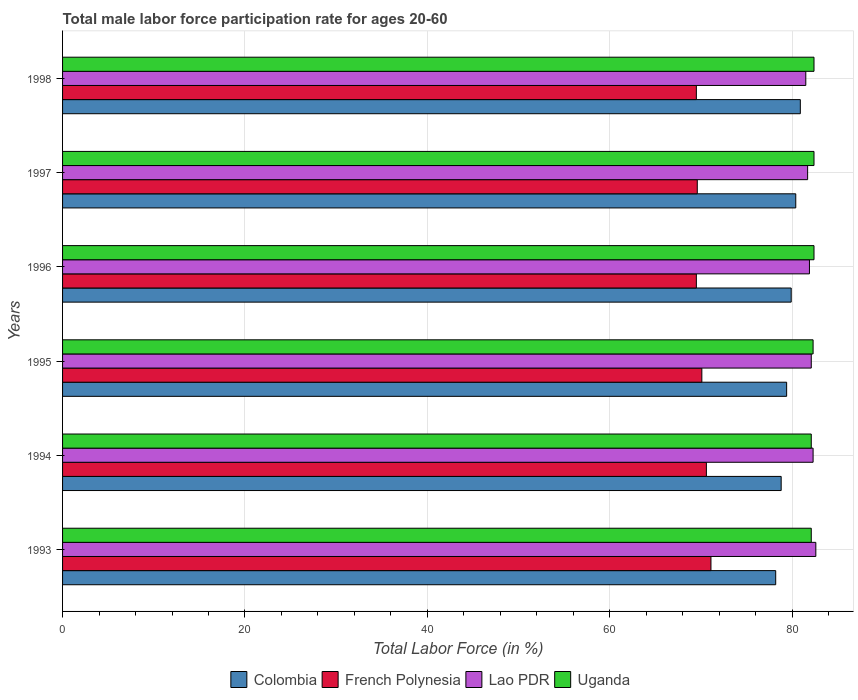How many different coloured bars are there?
Make the answer very short. 4. How many groups of bars are there?
Provide a succinct answer. 6. Are the number of bars per tick equal to the number of legend labels?
Offer a terse response. Yes. How many bars are there on the 2nd tick from the bottom?
Your response must be concise. 4. What is the label of the 1st group of bars from the top?
Offer a terse response. 1998. What is the male labor force participation rate in Lao PDR in 1998?
Provide a short and direct response. 81.5. Across all years, what is the maximum male labor force participation rate in Lao PDR?
Give a very brief answer. 82.6. Across all years, what is the minimum male labor force participation rate in Colombia?
Make the answer very short. 78.2. What is the total male labor force participation rate in Uganda in the graph?
Provide a short and direct response. 493.7. What is the difference between the male labor force participation rate in Colombia in 1994 and that in 1995?
Provide a succinct answer. -0.6. What is the difference between the male labor force participation rate in Lao PDR in 1994 and the male labor force participation rate in French Polynesia in 1996?
Provide a succinct answer. 12.8. What is the average male labor force participation rate in French Polynesia per year?
Keep it short and to the point. 70.07. In the year 1993, what is the difference between the male labor force participation rate in Colombia and male labor force participation rate in Lao PDR?
Keep it short and to the point. -4.4. What is the ratio of the male labor force participation rate in French Polynesia in 1993 to that in 1994?
Give a very brief answer. 1.01. Is the male labor force participation rate in Lao PDR in 1996 less than that in 1997?
Provide a succinct answer. No. Is the difference between the male labor force participation rate in Colombia in 1994 and 1997 greater than the difference between the male labor force participation rate in Lao PDR in 1994 and 1997?
Keep it short and to the point. No. What is the difference between the highest and the lowest male labor force participation rate in Colombia?
Offer a terse response. 2.7. In how many years, is the male labor force participation rate in Lao PDR greater than the average male labor force participation rate in Lao PDR taken over all years?
Ensure brevity in your answer.  3. Is the sum of the male labor force participation rate in French Polynesia in 1994 and 1995 greater than the maximum male labor force participation rate in Uganda across all years?
Make the answer very short. Yes. What does the 1st bar from the top in 1996 represents?
Your answer should be very brief. Uganda. What does the 3rd bar from the bottom in 1993 represents?
Your answer should be compact. Lao PDR. How many bars are there?
Provide a succinct answer. 24. How many years are there in the graph?
Provide a succinct answer. 6. Does the graph contain grids?
Ensure brevity in your answer.  Yes. Where does the legend appear in the graph?
Make the answer very short. Bottom center. How are the legend labels stacked?
Your answer should be compact. Horizontal. What is the title of the graph?
Offer a very short reply. Total male labor force participation rate for ages 20-60. Does "Mongolia" appear as one of the legend labels in the graph?
Provide a succinct answer. No. What is the label or title of the X-axis?
Provide a succinct answer. Total Labor Force (in %). What is the label or title of the Y-axis?
Your answer should be compact. Years. What is the Total Labor Force (in %) of Colombia in 1993?
Keep it short and to the point. 78.2. What is the Total Labor Force (in %) in French Polynesia in 1993?
Provide a succinct answer. 71.1. What is the Total Labor Force (in %) of Lao PDR in 1993?
Offer a very short reply. 82.6. What is the Total Labor Force (in %) in Uganda in 1993?
Your response must be concise. 82.1. What is the Total Labor Force (in %) of Colombia in 1994?
Your response must be concise. 78.8. What is the Total Labor Force (in %) in French Polynesia in 1994?
Your answer should be compact. 70.6. What is the Total Labor Force (in %) in Lao PDR in 1994?
Offer a terse response. 82.3. What is the Total Labor Force (in %) in Uganda in 1994?
Provide a short and direct response. 82.1. What is the Total Labor Force (in %) of Colombia in 1995?
Make the answer very short. 79.4. What is the Total Labor Force (in %) in French Polynesia in 1995?
Your answer should be compact. 70.1. What is the Total Labor Force (in %) of Lao PDR in 1995?
Make the answer very short. 82.1. What is the Total Labor Force (in %) of Uganda in 1995?
Your answer should be very brief. 82.3. What is the Total Labor Force (in %) in Colombia in 1996?
Offer a terse response. 79.9. What is the Total Labor Force (in %) in French Polynesia in 1996?
Offer a terse response. 69.5. What is the Total Labor Force (in %) in Lao PDR in 1996?
Offer a very short reply. 81.9. What is the Total Labor Force (in %) in Uganda in 1996?
Your answer should be very brief. 82.4. What is the Total Labor Force (in %) of Colombia in 1997?
Offer a terse response. 80.4. What is the Total Labor Force (in %) of French Polynesia in 1997?
Your response must be concise. 69.6. What is the Total Labor Force (in %) in Lao PDR in 1997?
Give a very brief answer. 81.7. What is the Total Labor Force (in %) in Uganda in 1997?
Your answer should be compact. 82.4. What is the Total Labor Force (in %) of Colombia in 1998?
Your answer should be very brief. 80.9. What is the Total Labor Force (in %) in French Polynesia in 1998?
Provide a short and direct response. 69.5. What is the Total Labor Force (in %) in Lao PDR in 1998?
Your answer should be very brief. 81.5. What is the Total Labor Force (in %) in Uganda in 1998?
Your response must be concise. 82.4. Across all years, what is the maximum Total Labor Force (in %) in Colombia?
Provide a short and direct response. 80.9. Across all years, what is the maximum Total Labor Force (in %) of French Polynesia?
Your answer should be compact. 71.1. Across all years, what is the maximum Total Labor Force (in %) of Lao PDR?
Your response must be concise. 82.6. Across all years, what is the maximum Total Labor Force (in %) in Uganda?
Provide a short and direct response. 82.4. Across all years, what is the minimum Total Labor Force (in %) of Colombia?
Provide a succinct answer. 78.2. Across all years, what is the minimum Total Labor Force (in %) of French Polynesia?
Keep it short and to the point. 69.5. Across all years, what is the minimum Total Labor Force (in %) of Lao PDR?
Provide a short and direct response. 81.5. Across all years, what is the minimum Total Labor Force (in %) of Uganda?
Give a very brief answer. 82.1. What is the total Total Labor Force (in %) in Colombia in the graph?
Your answer should be very brief. 477.6. What is the total Total Labor Force (in %) in French Polynesia in the graph?
Provide a succinct answer. 420.4. What is the total Total Labor Force (in %) in Lao PDR in the graph?
Offer a very short reply. 492.1. What is the total Total Labor Force (in %) in Uganda in the graph?
Your response must be concise. 493.7. What is the difference between the Total Labor Force (in %) of Uganda in 1993 and that in 1994?
Your answer should be very brief. 0. What is the difference between the Total Labor Force (in %) in French Polynesia in 1993 and that in 1995?
Offer a terse response. 1. What is the difference between the Total Labor Force (in %) in Lao PDR in 1993 and that in 1995?
Keep it short and to the point. 0.5. What is the difference between the Total Labor Force (in %) in Uganda in 1993 and that in 1995?
Provide a short and direct response. -0.2. What is the difference between the Total Labor Force (in %) in Colombia in 1993 and that in 1996?
Your answer should be compact. -1.7. What is the difference between the Total Labor Force (in %) in French Polynesia in 1993 and that in 1996?
Offer a very short reply. 1.6. What is the difference between the Total Labor Force (in %) in Lao PDR in 1993 and that in 1996?
Your answer should be compact. 0.7. What is the difference between the Total Labor Force (in %) in Uganda in 1993 and that in 1996?
Keep it short and to the point. -0.3. What is the difference between the Total Labor Force (in %) in Colombia in 1993 and that in 1997?
Keep it short and to the point. -2.2. What is the difference between the Total Labor Force (in %) of Lao PDR in 1993 and that in 1997?
Your response must be concise. 0.9. What is the difference between the Total Labor Force (in %) in French Polynesia in 1993 and that in 1998?
Ensure brevity in your answer.  1.6. What is the difference between the Total Labor Force (in %) of French Polynesia in 1994 and that in 1995?
Ensure brevity in your answer.  0.5. What is the difference between the Total Labor Force (in %) in Lao PDR in 1994 and that in 1995?
Provide a succinct answer. 0.2. What is the difference between the Total Labor Force (in %) of Uganda in 1994 and that in 1995?
Offer a terse response. -0.2. What is the difference between the Total Labor Force (in %) in French Polynesia in 1994 and that in 1996?
Your answer should be very brief. 1.1. What is the difference between the Total Labor Force (in %) of French Polynesia in 1994 and that in 1997?
Your answer should be very brief. 1. What is the difference between the Total Labor Force (in %) of Lao PDR in 1994 and that in 1997?
Offer a very short reply. 0.6. What is the difference between the Total Labor Force (in %) of French Polynesia in 1994 and that in 1998?
Offer a very short reply. 1.1. What is the difference between the Total Labor Force (in %) of Lao PDR in 1994 and that in 1998?
Your response must be concise. 0.8. What is the difference between the Total Labor Force (in %) of Uganda in 1994 and that in 1998?
Your response must be concise. -0.3. What is the difference between the Total Labor Force (in %) in Lao PDR in 1995 and that in 1996?
Offer a terse response. 0.2. What is the difference between the Total Labor Force (in %) of Colombia in 1995 and that in 1997?
Your response must be concise. -1. What is the difference between the Total Labor Force (in %) in French Polynesia in 1995 and that in 1997?
Offer a terse response. 0.5. What is the difference between the Total Labor Force (in %) in Uganda in 1995 and that in 1997?
Make the answer very short. -0.1. What is the difference between the Total Labor Force (in %) in Colombia in 1996 and that in 1997?
Your response must be concise. -0.5. What is the difference between the Total Labor Force (in %) of Uganda in 1996 and that in 1997?
Make the answer very short. 0. What is the difference between the Total Labor Force (in %) of Lao PDR in 1996 and that in 1998?
Give a very brief answer. 0.4. What is the difference between the Total Labor Force (in %) of Uganda in 1996 and that in 1998?
Offer a terse response. 0. What is the difference between the Total Labor Force (in %) of Lao PDR in 1997 and that in 1998?
Ensure brevity in your answer.  0.2. What is the difference between the Total Labor Force (in %) in Colombia in 1993 and the Total Labor Force (in %) in Uganda in 1994?
Offer a terse response. -3.9. What is the difference between the Total Labor Force (in %) in French Polynesia in 1993 and the Total Labor Force (in %) in Uganda in 1994?
Your answer should be compact. -11. What is the difference between the Total Labor Force (in %) in Colombia in 1993 and the Total Labor Force (in %) in French Polynesia in 1995?
Offer a terse response. 8.1. What is the difference between the Total Labor Force (in %) of French Polynesia in 1993 and the Total Labor Force (in %) of Uganda in 1995?
Offer a terse response. -11.2. What is the difference between the Total Labor Force (in %) in Colombia in 1993 and the Total Labor Force (in %) in French Polynesia in 1996?
Offer a very short reply. 8.7. What is the difference between the Total Labor Force (in %) in Colombia in 1993 and the Total Labor Force (in %) in Lao PDR in 1996?
Provide a short and direct response. -3.7. What is the difference between the Total Labor Force (in %) in Colombia in 1993 and the Total Labor Force (in %) in Uganda in 1996?
Offer a very short reply. -4.2. What is the difference between the Total Labor Force (in %) in French Polynesia in 1993 and the Total Labor Force (in %) in Uganda in 1996?
Offer a very short reply. -11.3. What is the difference between the Total Labor Force (in %) in Colombia in 1993 and the Total Labor Force (in %) in Lao PDR in 1997?
Make the answer very short. -3.5. What is the difference between the Total Labor Force (in %) in Colombia in 1993 and the Total Labor Force (in %) in Uganda in 1997?
Keep it short and to the point. -4.2. What is the difference between the Total Labor Force (in %) in French Polynesia in 1993 and the Total Labor Force (in %) in Lao PDR in 1997?
Your answer should be very brief. -10.6. What is the difference between the Total Labor Force (in %) of French Polynesia in 1993 and the Total Labor Force (in %) of Uganda in 1997?
Offer a terse response. -11.3. What is the difference between the Total Labor Force (in %) of Colombia in 1993 and the Total Labor Force (in %) of Uganda in 1998?
Keep it short and to the point. -4.2. What is the difference between the Total Labor Force (in %) in Lao PDR in 1993 and the Total Labor Force (in %) in Uganda in 1998?
Your response must be concise. 0.2. What is the difference between the Total Labor Force (in %) of Colombia in 1994 and the Total Labor Force (in %) of French Polynesia in 1995?
Ensure brevity in your answer.  8.7. What is the difference between the Total Labor Force (in %) in Colombia in 1994 and the Total Labor Force (in %) in Lao PDR in 1995?
Your response must be concise. -3.3. What is the difference between the Total Labor Force (in %) of French Polynesia in 1994 and the Total Labor Force (in %) of Uganda in 1995?
Provide a short and direct response. -11.7. What is the difference between the Total Labor Force (in %) in Lao PDR in 1994 and the Total Labor Force (in %) in Uganda in 1995?
Offer a terse response. 0. What is the difference between the Total Labor Force (in %) in Colombia in 1994 and the Total Labor Force (in %) in French Polynesia in 1996?
Your answer should be compact. 9.3. What is the difference between the Total Labor Force (in %) in Colombia in 1994 and the Total Labor Force (in %) in Lao PDR in 1996?
Give a very brief answer. -3.1. What is the difference between the Total Labor Force (in %) in French Polynesia in 1994 and the Total Labor Force (in %) in Lao PDR in 1996?
Offer a terse response. -11.3. What is the difference between the Total Labor Force (in %) of French Polynesia in 1994 and the Total Labor Force (in %) of Uganda in 1996?
Provide a succinct answer. -11.8. What is the difference between the Total Labor Force (in %) of Colombia in 1994 and the Total Labor Force (in %) of French Polynesia in 1997?
Your response must be concise. 9.2. What is the difference between the Total Labor Force (in %) of Colombia in 1994 and the Total Labor Force (in %) of Lao PDR in 1997?
Offer a very short reply. -2.9. What is the difference between the Total Labor Force (in %) of French Polynesia in 1994 and the Total Labor Force (in %) of Uganda in 1997?
Your response must be concise. -11.8. What is the difference between the Total Labor Force (in %) of Colombia in 1994 and the Total Labor Force (in %) of Uganda in 1998?
Give a very brief answer. -3.6. What is the difference between the Total Labor Force (in %) in French Polynesia in 1994 and the Total Labor Force (in %) in Lao PDR in 1998?
Your answer should be very brief. -10.9. What is the difference between the Total Labor Force (in %) in Colombia in 1995 and the Total Labor Force (in %) in Uganda in 1996?
Provide a succinct answer. -3. What is the difference between the Total Labor Force (in %) of French Polynesia in 1995 and the Total Labor Force (in %) of Uganda in 1996?
Ensure brevity in your answer.  -12.3. What is the difference between the Total Labor Force (in %) in Lao PDR in 1995 and the Total Labor Force (in %) in Uganda in 1996?
Give a very brief answer. -0.3. What is the difference between the Total Labor Force (in %) in Colombia in 1995 and the Total Labor Force (in %) in Uganda in 1997?
Your answer should be compact. -3. What is the difference between the Total Labor Force (in %) in French Polynesia in 1995 and the Total Labor Force (in %) in Lao PDR in 1997?
Provide a short and direct response. -11.6. What is the difference between the Total Labor Force (in %) of Lao PDR in 1995 and the Total Labor Force (in %) of Uganda in 1997?
Make the answer very short. -0.3. What is the difference between the Total Labor Force (in %) in Colombia in 1995 and the Total Labor Force (in %) in Lao PDR in 1998?
Ensure brevity in your answer.  -2.1. What is the difference between the Total Labor Force (in %) of Colombia in 1995 and the Total Labor Force (in %) of Uganda in 1998?
Your answer should be very brief. -3. What is the difference between the Total Labor Force (in %) of French Polynesia in 1996 and the Total Labor Force (in %) of Uganda in 1997?
Provide a short and direct response. -12.9. What is the difference between the Total Labor Force (in %) in Lao PDR in 1996 and the Total Labor Force (in %) in Uganda in 1997?
Provide a short and direct response. -0.5. What is the difference between the Total Labor Force (in %) of Colombia in 1996 and the Total Labor Force (in %) of Lao PDR in 1998?
Keep it short and to the point. -1.6. What is the difference between the Total Labor Force (in %) of French Polynesia in 1996 and the Total Labor Force (in %) of Lao PDR in 1998?
Give a very brief answer. -12. What is the difference between the Total Labor Force (in %) of Colombia in 1997 and the Total Labor Force (in %) of Lao PDR in 1998?
Your answer should be compact. -1.1. What is the difference between the Total Labor Force (in %) in Lao PDR in 1997 and the Total Labor Force (in %) in Uganda in 1998?
Make the answer very short. -0.7. What is the average Total Labor Force (in %) in Colombia per year?
Your answer should be compact. 79.6. What is the average Total Labor Force (in %) in French Polynesia per year?
Make the answer very short. 70.07. What is the average Total Labor Force (in %) in Lao PDR per year?
Give a very brief answer. 82.02. What is the average Total Labor Force (in %) in Uganda per year?
Your response must be concise. 82.28. In the year 1993, what is the difference between the Total Labor Force (in %) of French Polynesia and Total Labor Force (in %) of Lao PDR?
Provide a succinct answer. -11.5. In the year 1993, what is the difference between the Total Labor Force (in %) in French Polynesia and Total Labor Force (in %) in Uganda?
Your response must be concise. -11. In the year 1993, what is the difference between the Total Labor Force (in %) in Lao PDR and Total Labor Force (in %) in Uganda?
Give a very brief answer. 0.5. In the year 1994, what is the difference between the Total Labor Force (in %) of Colombia and Total Labor Force (in %) of French Polynesia?
Ensure brevity in your answer.  8.2. In the year 1994, what is the difference between the Total Labor Force (in %) in Colombia and Total Labor Force (in %) in Lao PDR?
Make the answer very short. -3.5. In the year 1994, what is the difference between the Total Labor Force (in %) in French Polynesia and Total Labor Force (in %) in Uganda?
Offer a terse response. -11.5. In the year 1994, what is the difference between the Total Labor Force (in %) in Lao PDR and Total Labor Force (in %) in Uganda?
Offer a very short reply. 0.2. In the year 1995, what is the difference between the Total Labor Force (in %) in Colombia and Total Labor Force (in %) in Uganda?
Keep it short and to the point. -2.9. In the year 1996, what is the difference between the Total Labor Force (in %) in Colombia and Total Labor Force (in %) in French Polynesia?
Your answer should be compact. 10.4. In the year 1996, what is the difference between the Total Labor Force (in %) in Colombia and Total Labor Force (in %) in Lao PDR?
Offer a terse response. -2. In the year 1996, what is the difference between the Total Labor Force (in %) of Colombia and Total Labor Force (in %) of Uganda?
Ensure brevity in your answer.  -2.5. In the year 1996, what is the difference between the Total Labor Force (in %) in Lao PDR and Total Labor Force (in %) in Uganda?
Your answer should be very brief. -0.5. In the year 1997, what is the difference between the Total Labor Force (in %) in Colombia and Total Labor Force (in %) in Uganda?
Ensure brevity in your answer.  -2. In the year 1997, what is the difference between the Total Labor Force (in %) of French Polynesia and Total Labor Force (in %) of Uganda?
Provide a short and direct response. -12.8. In the year 1997, what is the difference between the Total Labor Force (in %) in Lao PDR and Total Labor Force (in %) in Uganda?
Offer a very short reply. -0.7. In the year 1998, what is the difference between the Total Labor Force (in %) of Colombia and Total Labor Force (in %) of French Polynesia?
Keep it short and to the point. 11.4. In the year 1998, what is the difference between the Total Labor Force (in %) of Colombia and Total Labor Force (in %) of Lao PDR?
Keep it short and to the point. -0.6. In the year 1998, what is the difference between the Total Labor Force (in %) of Lao PDR and Total Labor Force (in %) of Uganda?
Offer a very short reply. -0.9. What is the ratio of the Total Labor Force (in %) in Colombia in 1993 to that in 1994?
Provide a succinct answer. 0.99. What is the ratio of the Total Labor Force (in %) of French Polynesia in 1993 to that in 1994?
Provide a short and direct response. 1.01. What is the ratio of the Total Labor Force (in %) of Lao PDR in 1993 to that in 1994?
Provide a succinct answer. 1. What is the ratio of the Total Labor Force (in %) in Uganda in 1993 to that in 1994?
Provide a succinct answer. 1. What is the ratio of the Total Labor Force (in %) in Colombia in 1993 to that in 1995?
Your answer should be very brief. 0.98. What is the ratio of the Total Labor Force (in %) of French Polynesia in 1993 to that in 1995?
Your answer should be very brief. 1.01. What is the ratio of the Total Labor Force (in %) in Colombia in 1993 to that in 1996?
Give a very brief answer. 0.98. What is the ratio of the Total Labor Force (in %) of French Polynesia in 1993 to that in 1996?
Offer a very short reply. 1.02. What is the ratio of the Total Labor Force (in %) of Lao PDR in 1993 to that in 1996?
Keep it short and to the point. 1.01. What is the ratio of the Total Labor Force (in %) in Uganda in 1993 to that in 1996?
Provide a short and direct response. 1. What is the ratio of the Total Labor Force (in %) of Colombia in 1993 to that in 1997?
Ensure brevity in your answer.  0.97. What is the ratio of the Total Labor Force (in %) of French Polynesia in 1993 to that in 1997?
Your response must be concise. 1.02. What is the ratio of the Total Labor Force (in %) in Colombia in 1993 to that in 1998?
Offer a terse response. 0.97. What is the ratio of the Total Labor Force (in %) in French Polynesia in 1993 to that in 1998?
Keep it short and to the point. 1.02. What is the ratio of the Total Labor Force (in %) of Lao PDR in 1993 to that in 1998?
Provide a succinct answer. 1.01. What is the ratio of the Total Labor Force (in %) in Uganda in 1993 to that in 1998?
Offer a very short reply. 1. What is the ratio of the Total Labor Force (in %) in Colombia in 1994 to that in 1995?
Provide a succinct answer. 0.99. What is the ratio of the Total Labor Force (in %) in French Polynesia in 1994 to that in 1995?
Give a very brief answer. 1.01. What is the ratio of the Total Labor Force (in %) of Lao PDR in 1994 to that in 1995?
Provide a short and direct response. 1. What is the ratio of the Total Labor Force (in %) in Colombia in 1994 to that in 1996?
Your answer should be very brief. 0.99. What is the ratio of the Total Labor Force (in %) in French Polynesia in 1994 to that in 1996?
Offer a terse response. 1.02. What is the ratio of the Total Labor Force (in %) in Uganda in 1994 to that in 1996?
Offer a terse response. 1. What is the ratio of the Total Labor Force (in %) of Colombia in 1994 to that in 1997?
Your answer should be very brief. 0.98. What is the ratio of the Total Labor Force (in %) of French Polynesia in 1994 to that in 1997?
Provide a short and direct response. 1.01. What is the ratio of the Total Labor Force (in %) in Lao PDR in 1994 to that in 1997?
Offer a very short reply. 1.01. What is the ratio of the Total Labor Force (in %) of Colombia in 1994 to that in 1998?
Your answer should be very brief. 0.97. What is the ratio of the Total Labor Force (in %) of French Polynesia in 1994 to that in 1998?
Keep it short and to the point. 1.02. What is the ratio of the Total Labor Force (in %) in Lao PDR in 1994 to that in 1998?
Make the answer very short. 1.01. What is the ratio of the Total Labor Force (in %) in Uganda in 1994 to that in 1998?
Make the answer very short. 1. What is the ratio of the Total Labor Force (in %) in Colombia in 1995 to that in 1996?
Ensure brevity in your answer.  0.99. What is the ratio of the Total Labor Force (in %) of French Polynesia in 1995 to that in 1996?
Your answer should be compact. 1.01. What is the ratio of the Total Labor Force (in %) in Lao PDR in 1995 to that in 1996?
Your answer should be very brief. 1. What is the ratio of the Total Labor Force (in %) in Colombia in 1995 to that in 1997?
Your response must be concise. 0.99. What is the ratio of the Total Labor Force (in %) of French Polynesia in 1995 to that in 1997?
Give a very brief answer. 1.01. What is the ratio of the Total Labor Force (in %) of Lao PDR in 1995 to that in 1997?
Your response must be concise. 1. What is the ratio of the Total Labor Force (in %) of Uganda in 1995 to that in 1997?
Your response must be concise. 1. What is the ratio of the Total Labor Force (in %) of Colombia in 1995 to that in 1998?
Offer a terse response. 0.98. What is the ratio of the Total Labor Force (in %) in French Polynesia in 1995 to that in 1998?
Make the answer very short. 1.01. What is the ratio of the Total Labor Force (in %) of Lao PDR in 1995 to that in 1998?
Provide a short and direct response. 1.01. What is the ratio of the Total Labor Force (in %) of Colombia in 1996 to that in 1997?
Ensure brevity in your answer.  0.99. What is the ratio of the Total Labor Force (in %) of Lao PDR in 1996 to that in 1997?
Your response must be concise. 1. What is the ratio of the Total Labor Force (in %) of Uganda in 1996 to that in 1997?
Give a very brief answer. 1. What is the ratio of the Total Labor Force (in %) of Colombia in 1996 to that in 1998?
Make the answer very short. 0.99. What is the ratio of the Total Labor Force (in %) in Lao PDR in 1996 to that in 1998?
Offer a terse response. 1. What is the ratio of the Total Labor Force (in %) in Uganda in 1996 to that in 1998?
Offer a terse response. 1. What is the ratio of the Total Labor Force (in %) in Lao PDR in 1997 to that in 1998?
Provide a succinct answer. 1. What is the difference between the highest and the second highest Total Labor Force (in %) in Colombia?
Give a very brief answer. 0.5. What is the difference between the highest and the second highest Total Labor Force (in %) of Lao PDR?
Keep it short and to the point. 0.3. What is the difference between the highest and the second highest Total Labor Force (in %) of Uganda?
Provide a short and direct response. 0. What is the difference between the highest and the lowest Total Labor Force (in %) of Lao PDR?
Provide a short and direct response. 1.1. 